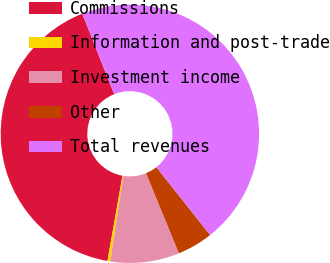Convert chart to OTSL. <chart><loc_0><loc_0><loc_500><loc_500><pie_chart><fcel>Commissions<fcel>Information and post-trade<fcel>Investment income<fcel>Other<fcel>Total revenues<nl><fcel>41.21%<fcel>0.35%<fcel>8.62%<fcel>4.48%<fcel>45.34%<nl></chart> 